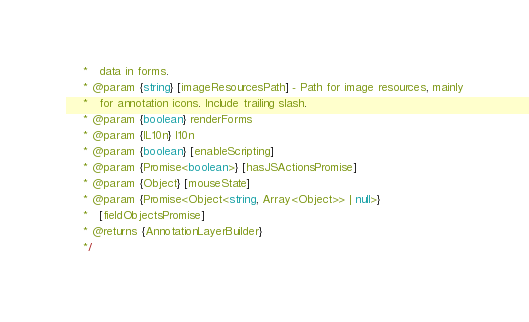Convert code to text. <code><loc_0><loc_0><loc_500><loc_500><_TypeScript_>     *   data in forms.
     * @param {string} [imageResourcesPath] - Path for image resources, mainly
     *   for annotation icons. Include trailing slash.
     * @param {boolean} renderForms
     * @param {IL10n} l10n
     * @param {boolean} [enableScripting]
     * @param {Promise<boolean>} [hasJSActionsPromise]
     * @param {Object} [mouseState]
     * @param {Promise<Object<string, Array<Object>> | null>}
     *   [fieldObjectsPromise]
     * @returns {AnnotationLayerBuilder}
     */</code> 